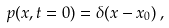Convert formula to latex. <formula><loc_0><loc_0><loc_500><loc_500>p ( x , t = 0 ) = \delta ( x - x _ { 0 } ) \, ,</formula> 